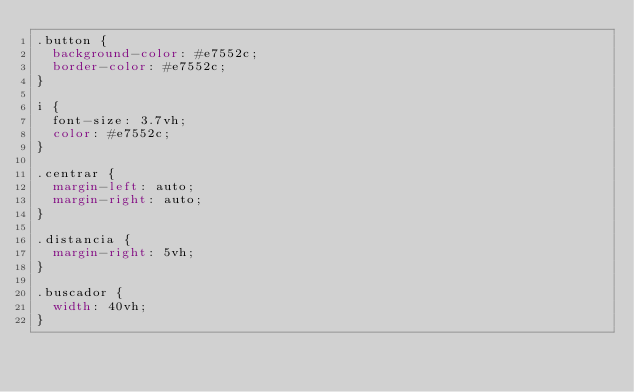Convert code to text. <code><loc_0><loc_0><loc_500><loc_500><_CSS_>.button {
  background-color: #e7552c;
  border-color: #e7552c;
}

i {
  font-size: 3.7vh;
  color: #e7552c;
}

.centrar {
  margin-left: auto;
  margin-right: auto;
}

.distancia {
  margin-right: 5vh;
}

.buscador {
  width: 40vh;
}
</code> 